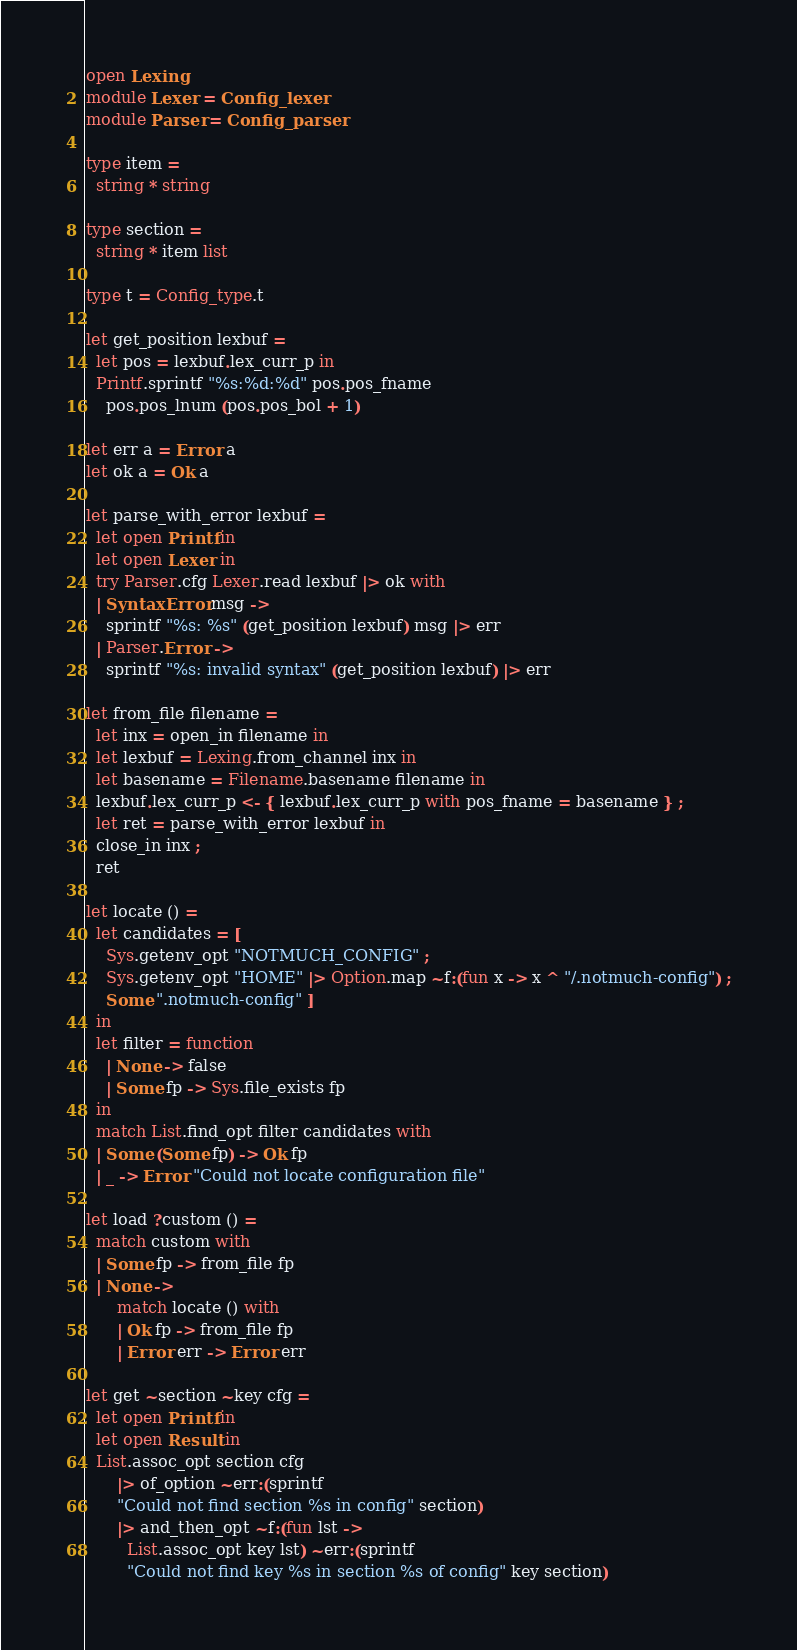Convert code to text. <code><loc_0><loc_0><loc_500><loc_500><_OCaml_>open Lexing
module Lexer = Config_lexer
module Parser = Config_parser

type item =
  string * string

type section =
  string * item list

type t = Config_type.t

let get_position lexbuf =
  let pos = lexbuf.lex_curr_p in
  Printf.sprintf "%s:%d:%d" pos.pos_fname
    pos.pos_lnum (pos.pos_bol + 1)

let err a = Error a
let ok a = Ok a

let parse_with_error lexbuf =
  let open Printf in
  let open Lexer in
  try Parser.cfg Lexer.read lexbuf |> ok with
  | SyntaxError msg ->
    sprintf "%s: %s" (get_position lexbuf) msg |> err
  | Parser.Error ->
    sprintf "%s: invalid syntax" (get_position lexbuf) |> err

let from_file filename =
  let inx = open_in filename in
  let lexbuf = Lexing.from_channel inx in
  let basename = Filename.basename filename in
  lexbuf.lex_curr_p <- { lexbuf.lex_curr_p with pos_fname = basename } ;
  let ret = parse_with_error lexbuf in
  close_in inx ;
  ret

let locate () =
  let candidates = [
    Sys.getenv_opt "NOTMUCH_CONFIG" ;
    Sys.getenv_opt "HOME" |> Option.map ~f:(fun x -> x ^ "/.notmuch-config") ;
    Some ".notmuch-config" ]
  in
  let filter = function
    | None -> false
    | Some fp -> Sys.file_exists fp
  in
  match List.find_opt filter candidates with
  | Some (Some fp) -> Ok fp
  | _ -> Error "Could not locate configuration file"

let load ?custom () =
  match custom with
  | Some fp -> from_file fp
  | None ->
      match locate () with
      | Ok fp -> from_file fp
      | Error err -> Error err

let get ~section ~key cfg =
  let open Printf in
  let open Result in
  List.assoc_opt section cfg
      |> of_option ~err:(sprintf
      "Could not find section %s in config" section)
      |> and_then_opt ~f:(fun lst ->
        List.assoc_opt key lst) ~err:(sprintf
        "Could not find key %s in section %s of config" key section)
</code> 